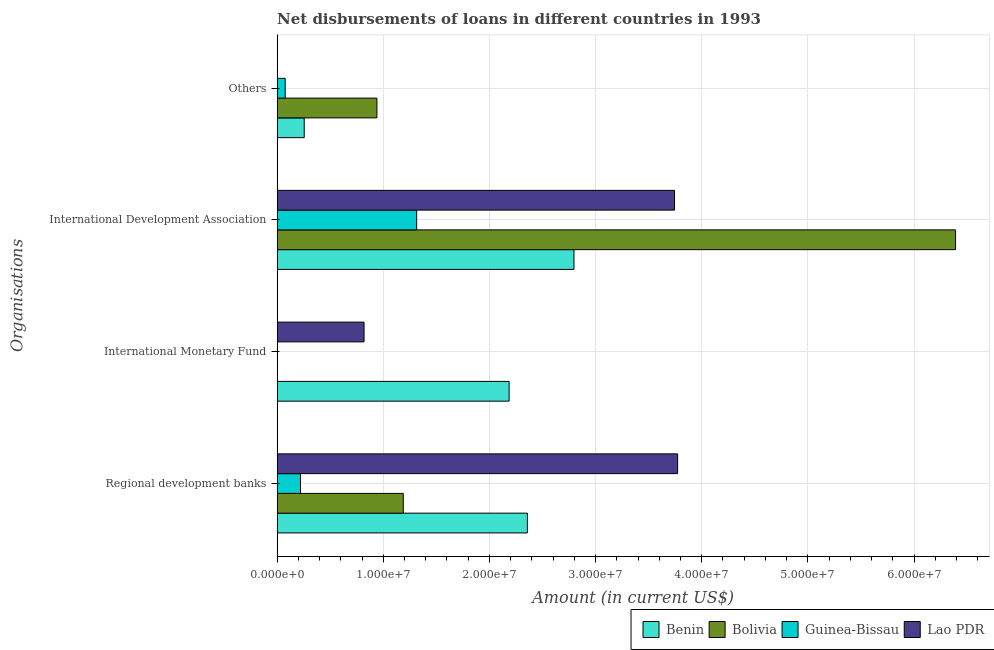How many different coloured bars are there?
Your answer should be very brief. 4. Are the number of bars per tick equal to the number of legend labels?
Provide a short and direct response. No. How many bars are there on the 2nd tick from the top?
Ensure brevity in your answer.  4. What is the label of the 1st group of bars from the top?
Offer a very short reply. Others. What is the amount of loan disimbursed by international development association in Benin?
Ensure brevity in your answer.  2.80e+07. Across all countries, what is the maximum amount of loan disimbursed by regional development banks?
Provide a short and direct response. 3.77e+07. Across all countries, what is the minimum amount of loan disimbursed by regional development banks?
Provide a short and direct response. 2.20e+06. In which country was the amount of loan disimbursed by international development association maximum?
Your response must be concise. Bolivia. What is the total amount of loan disimbursed by international monetary fund in the graph?
Offer a terse response. 3.00e+07. What is the difference between the amount of loan disimbursed by other organisations in Benin and that in Guinea-Bissau?
Your response must be concise. 1.79e+06. What is the difference between the amount of loan disimbursed by international monetary fund in Benin and the amount of loan disimbursed by international development association in Lao PDR?
Your response must be concise. -1.56e+07. What is the average amount of loan disimbursed by international development association per country?
Offer a very short reply. 3.56e+07. What is the difference between the amount of loan disimbursed by other organisations and amount of loan disimbursed by international monetary fund in Benin?
Provide a succinct answer. -1.93e+07. In how many countries, is the amount of loan disimbursed by other organisations greater than 6000000 US$?
Ensure brevity in your answer.  1. What is the ratio of the amount of loan disimbursed by international development association in Lao PDR to that in Bolivia?
Give a very brief answer. 0.59. Is the difference between the amount of loan disimbursed by other organisations in Bolivia and Benin greater than the difference between the amount of loan disimbursed by regional development banks in Bolivia and Benin?
Ensure brevity in your answer.  Yes. What is the difference between the highest and the second highest amount of loan disimbursed by other organisations?
Provide a short and direct response. 6.85e+06. What is the difference between the highest and the lowest amount of loan disimbursed by international development association?
Your answer should be very brief. 5.08e+07. In how many countries, is the amount of loan disimbursed by international monetary fund greater than the average amount of loan disimbursed by international monetary fund taken over all countries?
Make the answer very short. 2. Is the sum of the amount of loan disimbursed by regional development banks in Lao PDR and Benin greater than the maximum amount of loan disimbursed by other organisations across all countries?
Your answer should be compact. Yes. Is it the case that in every country, the sum of the amount of loan disimbursed by international development association and amount of loan disimbursed by international monetary fund is greater than the sum of amount of loan disimbursed by regional development banks and amount of loan disimbursed by other organisations?
Provide a succinct answer. No. Is it the case that in every country, the sum of the amount of loan disimbursed by regional development banks and amount of loan disimbursed by international monetary fund is greater than the amount of loan disimbursed by international development association?
Your response must be concise. No. Are all the bars in the graph horizontal?
Your answer should be compact. Yes. How many countries are there in the graph?
Provide a short and direct response. 4. What is the difference between two consecutive major ticks on the X-axis?
Provide a succinct answer. 1.00e+07. Are the values on the major ticks of X-axis written in scientific E-notation?
Ensure brevity in your answer.  Yes. Does the graph contain any zero values?
Make the answer very short. Yes. Does the graph contain grids?
Your answer should be very brief. Yes. Where does the legend appear in the graph?
Ensure brevity in your answer.  Bottom right. How many legend labels are there?
Your response must be concise. 4. How are the legend labels stacked?
Offer a terse response. Horizontal. What is the title of the graph?
Provide a short and direct response. Net disbursements of loans in different countries in 1993. Does "Kuwait" appear as one of the legend labels in the graph?
Your response must be concise. No. What is the label or title of the Y-axis?
Your answer should be compact. Organisations. What is the Amount (in current US$) of Benin in Regional development banks?
Make the answer very short. 2.36e+07. What is the Amount (in current US$) of Bolivia in Regional development banks?
Give a very brief answer. 1.19e+07. What is the Amount (in current US$) of Guinea-Bissau in Regional development banks?
Provide a succinct answer. 2.20e+06. What is the Amount (in current US$) in Lao PDR in Regional development banks?
Your response must be concise. 3.77e+07. What is the Amount (in current US$) of Benin in International Monetary Fund?
Offer a very short reply. 2.19e+07. What is the Amount (in current US$) in Lao PDR in International Monetary Fund?
Keep it short and to the point. 8.19e+06. What is the Amount (in current US$) of Benin in International Development Association?
Your response must be concise. 2.80e+07. What is the Amount (in current US$) of Bolivia in International Development Association?
Offer a terse response. 6.39e+07. What is the Amount (in current US$) of Guinea-Bissau in International Development Association?
Your response must be concise. 1.31e+07. What is the Amount (in current US$) in Lao PDR in International Development Association?
Offer a very short reply. 3.74e+07. What is the Amount (in current US$) in Benin in Others?
Make the answer very short. 2.55e+06. What is the Amount (in current US$) of Bolivia in Others?
Your response must be concise. 9.40e+06. What is the Amount (in current US$) in Guinea-Bissau in Others?
Provide a short and direct response. 7.60e+05. What is the Amount (in current US$) of Lao PDR in Others?
Offer a very short reply. 0. Across all Organisations, what is the maximum Amount (in current US$) of Benin?
Your answer should be compact. 2.80e+07. Across all Organisations, what is the maximum Amount (in current US$) of Bolivia?
Your response must be concise. 6.39e+07. Across all Organisations, what is the maximum Amount (in current US$) of Guinea-Bissau?
Offer a very short reply. 1.31e+07. Across all Organisations, what is the maximum Amount (in current US$) of Lao PDR?
Keep it short and to the point. 3.77e+07. Across all Organisations, what is the minimum Amount (in current US$) in Benin?
Your response must be concise. 2.55e+06. Across all Organisations, what is the minimum Amount (in current US$) of Bolivia?
Offer a terse response. 0. Across all Organisations, what is the minimum Amount (in current US$) in Lao PDR?
Provide a short and direct response. 0. What is the total Amount (in current US$) in Benin in the graph?
Your response must be concise. 7.60e+07. What is the total Amount (in current US$) in Bolivia in the graph?
Keep it short and to the point. 8.52e+07. What is the total Amount (in current US$) of Guinea-Bissau in the graph?
Offer a terse response. 1.61e+07. What is the total Amount (in current US$) of Lao PDR in the graph?
Offer a terse response. 8.34e+07. What is the difference between the Amount (in current US$) in Benin in Regional development banks and that in International Monetary Fund?
Your answer should be compact. 1.72e+06. What is the difference between the Amount (in current US$) of Lao PDR in Regional development banks and that in International Monetary Fund?
Give a very brief answer. 2.95e+07. What is the difference between the Amount (in current US$) in Benin in Regional development banks and that in International Development Association?
Make the answer very short. -4.39e+06. What is the difference between the Amount (in current US$) in Bolivia in Regional development banks and that in International Development Association?
Make the answer very short. -5.20e+07. What is the difference between the Amount (in current US$) of Guinea-Bissau in Regional development banks and that in International Development Association?
Your response must be concise. -1.09e+07. What is the difference between the Amount (in current US$) in Lao PDR in Regional development banks and that in International Development Association?
Provide a short and direct response. 2.90e+05. What is the difference between the Amount (in current US$) in Benin in Regional development banks and that in Others?
Provide a short and direct response. 2.10e+07. What is the difference between the Amount (in current US$) in Bolivia in Regional development banks and that in Others?
Give a very brief answer. 2.48e+06. What is the difference between the Amount (in current US$) in Guinea-Bissau in Regional development banks and that in Others?
Provide a succinct answer. 1.44e+06. What is the difference between the Amount (in current US$) of Benin in International Monetary Fund and that in International Development Association?
Make the answer very short. -6.11e+06. What is the difference between the Amount (in current US$) of Lao PDR in International Monetary Fund and that in International Development Association?
Your answer should be compact. -2.92e+07. What is the difference between the Amount (in current US$) in Benin in International Monetary Fund and that in Others?
Keep it short and to the point. 1.93e+07. What is the difference between the Amount (in current US$) in Benin in International Development Association and that in Others?
Give a very brief answer. 2.54e+07. What is the difference between the Amount (in current US$) in Bolivia in International Development Association and that in Others?
Keep it short and to the point. 5.45e+07. What is the difference between the Amount (in current US$) of Guinea-Bissau in International Development Association and that in Others?
Give a very brief answer. 1.24e+07. What is the difference between the Amount (in current US$) of Benin in Regional development banks and the Amount (in current US$) of Lao PDR in International Monetary Fund?
Provide a succinct answer. 1.54e+07. What is the difference between the Amount (in current US$) of Bolivia in Regional development banks and the Amount (in current US$) of Lao PDR in International Monetary Fund?
Your response must be concise. 3.69e+06. What is the difference between the Amount (in current US$) of Guinea-Bissau in Regional development banks and the Amount (in current US$) of Lao PDR in International Monetary Fund?
Keep it short and to the point. -5.99e+06. What is the difference between the Amount (in current US$) in Benin in Regional development banks and the Amount (in current US$) in Bolivia in International Development Association?
Keep it short and to the point. -4.03e+07. What is the difference between the Amount (in current US$) in Benin in Regional development banks and the Amount (in current US$) in Guinea-Bissau in International Development Association?
Provide a succinct answer. 1.04e+07. What is the difference between the Amount (in current US$) in Benin in Regional development banks and the Amount (in current US$) in Lao PDR in International Development Association?
Ensure brevity in your answer.  -1.39e+07. What is the difference between the Amount (in current US$) of Bolivia in Regional development banks and the Amount (in current US$) of Guinea-Bissau in International Development Association?
Keep it short and to the point. -1.26e+06. What is the difference between the Amount (in current US$) in Bolivia in Regional development banks and the Amount (in current US$) in Lao PDR in International Development Association?
Ensure brevity in your answer.  -2.56e+07. What is the difference between the Amount (in current US$) of Guinea-Bissau in Regional development banks and the Amount (in current US$) of Lao PDR in International Development Association?
Your answer should be very brief. -3.52e+07. What is the difference between the Amount (in current US$) in Benin in Regional development banks and the Amount (in current US$) in Bolivia in Others?
Provide a short and direct response. 1.42e+07. What is the difference between the Amount (in current US$) of Benin in Regional development banks and the Amount (in current US$) of Guinea-Bissau in Others?
Provide a short and direct response. 2.28e+07. What is the difference between the Amount (in current US$) in Bolivia in Regional development banks and the Amount (in current US$) in Guinea-Bissau in Others?
Provide a short and direct response. 1.11e+07. What is the difference between the Amount (in current US$) of Benin in International Monetary Fund and the Amount (in current US$) of Bolivia in International Development Association?
Offer a terse response. -4.21e+07. What is the difference between the Amount (in current US$) of Benin in International Monetary Fund and the Amount (in current US$) of Guinea-Bissau in International Development Association?
Your response must be concise. 8.71e+06. What is the difference between the Amount (in current US$) in Benin in International Monetary Fund and the Amount (in current US$) in Lao PDR in International Development Association?
Your response must be concise. -1.56e+07. What is the difference between the Amount (in current US$) of Benin in International Monetary Fund and the Amount (in current US$) of Bolivia in Others?
Make the answer very short. 1.25e+07. What is the difference between the Amount (in current US$) of Benin in International Monetary Fund and the Amount (in current US$) of Guinea-Bissau in Others?
Provide a short and direct response. 2.11e+07. What is the difference between the Amount (in current US$) of Benin in International Development Association and the Amount (in current US$) of Bolivia in Others?
Your answer should be very brief. 1.86e+07. What is the difference between the Amount (in current US$) in Benin in International Development Association and the Amount (in current US$) in Guinea-Bissau in Others?
Provide a short and direct response. 2.72e+07. What is the difference between the Amount (in current US$) in Bolivia in International Development Association and the Amount (in current US$) in Guinea-Bissau in Others?
Give a very brief answer. 6.32e+07. What is the average Amount (in current US$) of Benin per Organisations?
Your answer should be very brief. 1.90e+07. What is the average Amount (in current US$) of Bolivia per Organisations?
Provide a succinct answer. 2.13e+07. What is the average Amount (in current US$) in Guinea-Bissau per Organisations?
Keep it short and to the point. 4.03e+06. What is the average Amount (in current US$) in Lao PDR per Organisations?
Offer a very short reply. 2.08e+07. What is the difference between the Amount (in current US$) in Benin and Amount (in current US$) in Bolivia in Regional development banks?
Provide a succinct answer. 1.17e+07. What is the difference between the Amount (in current US$) in Benin and Amount (in current US$) in Guinea-Bissau in Regional development banks?
Offer a very short reply. 2.14e+07. What is the difference between the Amount (in current US$) of Benin and Amount (in current US$) of Lao PDR in Regional development banks?
Offer a very short reply. -1.42e+07. What is the difference between the Amount (in current US$) in Bolivia and Amount (in current US$) in Guinea-Bissau in Regional development banks?
Make the answer very short. 9.68e+06. What is the difference between the Amount (in current US$) in Bolivia and Amount (in current US$) in Lao PDR in Regional development banks?
Make the answer very short. -2.58e+07. What is the difference between the Amount (in current US$) in Guinea-Bissau and Amount (in current US$) in Lao PDR in Regional development banks?
Provide a succinct answer. -3.55e+07. What is the difference between the Amount (in current US$) of Benin and Amount (in current US$) of Lao PDR in International Monetary Fund?
Keep it short and to the point. 1.37e+07. What is the difference between the Amount (in current US$) of Benin and Amount (in current US$) of Bolivia in International Development Association?
Make the answer very short. -3.59e+07. What is the difference between the Amount (in current US$) of Benin and Amount (in current US$) of Guinea-Bissau in International Development Association?
Provide a short and direct response. 1.48e+07. What is the difference between the Amount (in current US$) of Benin and Amount (in current US$) of Lao PDR in International Development Association?
Your answer should be compact. -9.47e+06. What is the difference between the Amount (in current US$) in Bolivia and Amount (in current US$) in Guinea-Bissau in International Development Association?
Ensure brevity in your answer.  5.08e+07. What is the difference between the Amount (in current US$) of Bolivia and Amount (in current US$) of Lao PDR in International Development Association?
Provide a short and direct response. 2.65e+07. What is the difference between the Amount (in current US$) in Guinea-Bissau and Amount (in current US$) in Lao PDR in International Development Association?
Keep it short and to the point. -2.43e+07. What is the difference between the Amount (in current US$) of Benin and Amount (in current US$) of Bolivia in Others?
Give a very brief answer. -6.85e+06. What is the difference between the Amount (in current US$) in Benin and Amount (in current US$) in Guinea-Bissau in Others?
Offer a very short reply. 1.79e+06. What is the difference between the Amount (in current US$) of Bolivia and Amount (in current US$) of Guinea-Bissau in Others?
Provide a short and direct response. 8.64e+06. What is the ratio of the Amount (in current US$) in Benin in Regional development banks to that in International Monetary Fund?
Keep it short and to the point. 1.08. What is the ratio of the Amount (in current US$) of Lao PDR in Regional development banks to that in International Monetary Fund?
Your answer should be very brief. 4.61. What is the ratio of the Amount (in current US$) of Benin in Regional development banks to that in International Development Association?
Provide a succinct answer. 0.84. What is the ratio of the Amount (in current US$) in Bolivia in Regional development banks to that in International Development Association?
Keep it short and to the point. 0.19. What is the ratio of the Amount (in current US$) of Guinea-Bissau in Regional development banks to that in International Development Association?
Provide a succinct answer. 0.17. What is the ratio of the Amount (in current US$) in Lao PDR in Regional development banks to that in International Development Association?
Provide a succinct answer. 1.01. What is the ratio of the Amount (in current US$) in Benin in Regional development banks to that in Others?
Offer a very short reply. 9.23. What is the ratio of the Amount (in current US$) of Bolivia in Regional development banks to that in Others?
Your answer should be compact. 1.26. What is the ratio of the Amount (in current US$) in Guinea-Bissau in Regional development banks to that in Others?
Offer a terse response. 2.89. What is the ratio of the Amount (in current US$) in Benin in International Monetary Fund to that in International Development Association?
Make the answer very short. 0.78. What is the ratio of the Amount (in current US$) in Lao PDR in International Monetary Fund to that in International Development Association?
Provide a short and direct response. 0.22. What is the ratio of the Amount (in current US$) in Benin in International Monetary Fund to that in Others?
Keep it short and to the point. 8.56. What is the ratio of the Amount (in current US$) of Benin in International Development Association to that in Others?
Offer a terse response. 10.95. What is the ratio of the Amount (in current US$) of Bolivia in International Development Association to that in Others?
Offer a very short reply. 6.8. What is the ratio of the Amount (in current US$) of Guinea-Bissau in International Development Association to that in Others?
Ensure brevity in your answer.  17.3. What is the difference between the highest and the second highest Amount (in current US$) in Benin?
Your answer should be compact. 4.39e+06. What is the difference between the highest and the second highest Amount (in current US$) of Bolivia?
Give a very brief answer. 5.20e+07. What is the difference between the highest and the second highest Amount (in current US$) in Guinea-Bissau?
Offer a very short reply. 1.09e+07. What is the difference between the highest and the second highest Amount (in current US$) in Lao PDR?
Your answer should be compact. 2.90e+05. What is the difference between the highest and the lowest Amount (in current US$) of Benin?
Provide a succinct answer. 2.54e+07. What is the difference between the highest and the lowest Amount (in current US$) in Bolivia?
Ensure brevity in your answer.  6.39e+07. What is the difference between the highest and the lowest Amount (in current US$) of Guinea-Bissau?
Provide a succinct answer. 1.31e+07. What is the difference between the highest and the lowest Amount (in current US$) in Lao PDR?
Keep it short and to the point. 3.77e+07. 